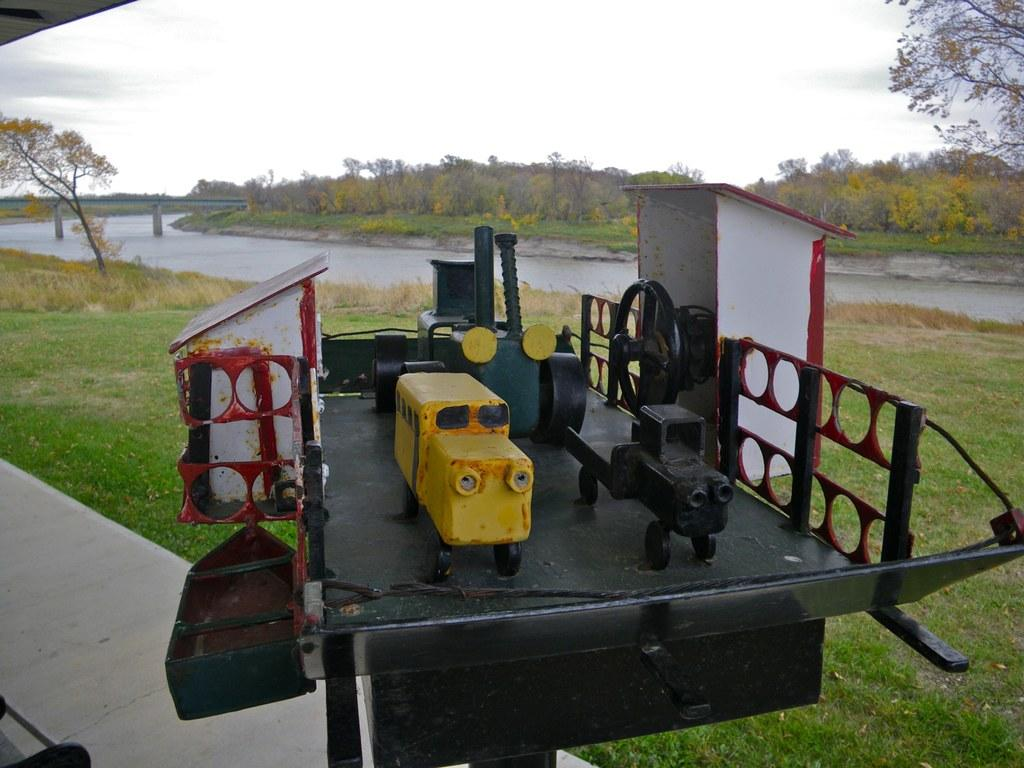What type of toys are in the image? There are yellow and black iron toys in the image. Where are the toys placed? The toys are placed on a black table. What can be seen in the background of the image? There is a small river and trees visible in the background of the image. Who is laughing in the lunchroom in the image? There is no lunchroom or anyone laughing present in the image. The image features yellow and black iron toys placed on a black table, with a small river and trees visible in the background. 